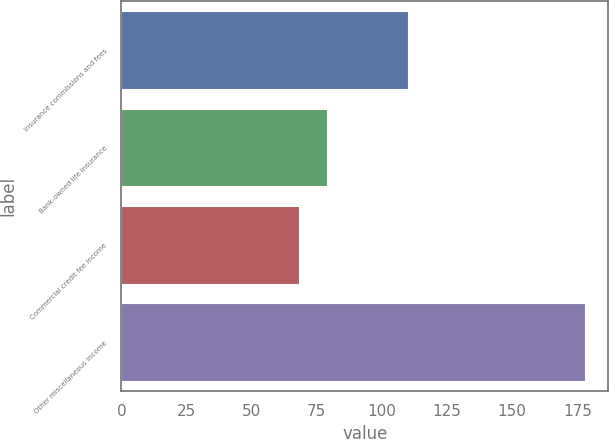<chart> <loc_0><loc_0><loc_500><loc_500><bar_chart><fcel>Insurance commissions and fees<fcel>Bank-owned life insurance<fcel>Commercial credit fee income<fcel>Other miscellaneous income<nl><fcel>110<fcel>79<fcel>68<fcel>178<nl></chart> 